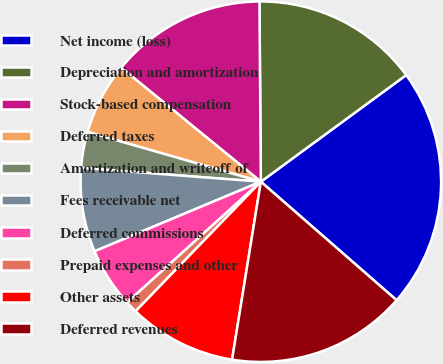<chart> <loc_0><loc_0><loc_500><loc_500><pie_chart><fcel>Net income (loss)<fcel>Depreciation and amortization<fcel>Stock-based compensation<fcel>Deferred taxes<fcel>Amortization and writeoff of<fcel>Fees receivable net<fcel>Deferred commissions<fcel>Prepaid expenses and other<fcel>Other assets<fcel>Deferred revenues<nl><fcel>21.5%<fcel>15.05%<fcel>13.98%<fcel>6.45%<fcel>3.23%<fcel>7.53%<fcel>5.38%<fcel>1.08%<fcel>9.68%<fcel>16.13%<nl></chart> 